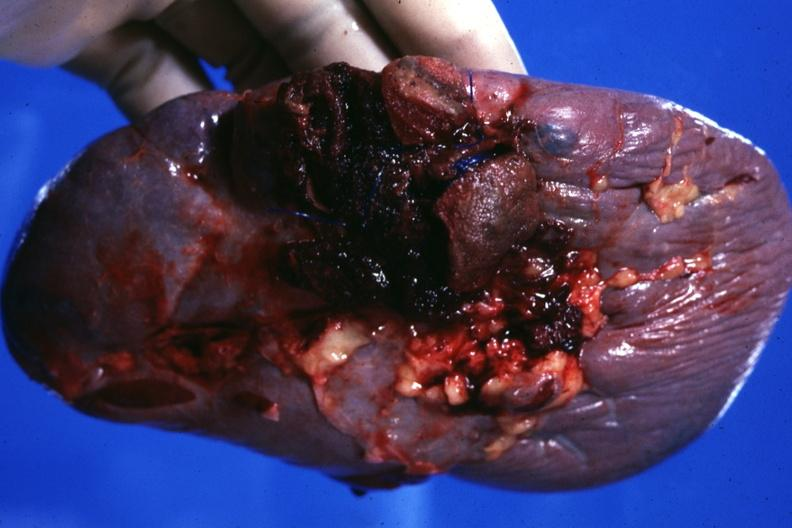does pulmonary osteoarthropathy show close-up of ruptured area very good?
Answer the question using a single word or phrase. No 